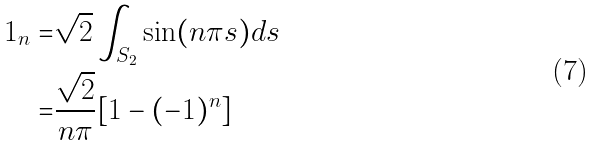Convert formula to latex. <formula><loc_0><loc_0><loc_500><loc_500>1 _ { n } = & \sqrt { 2 } \int _ { S _ { 2 } } \sin ( n \pi s ) d s \\ = & \frac { \sqrt { 2 } } { n \pi } [ 1 - ( - 1 ) ^ { n } ]</formula> 